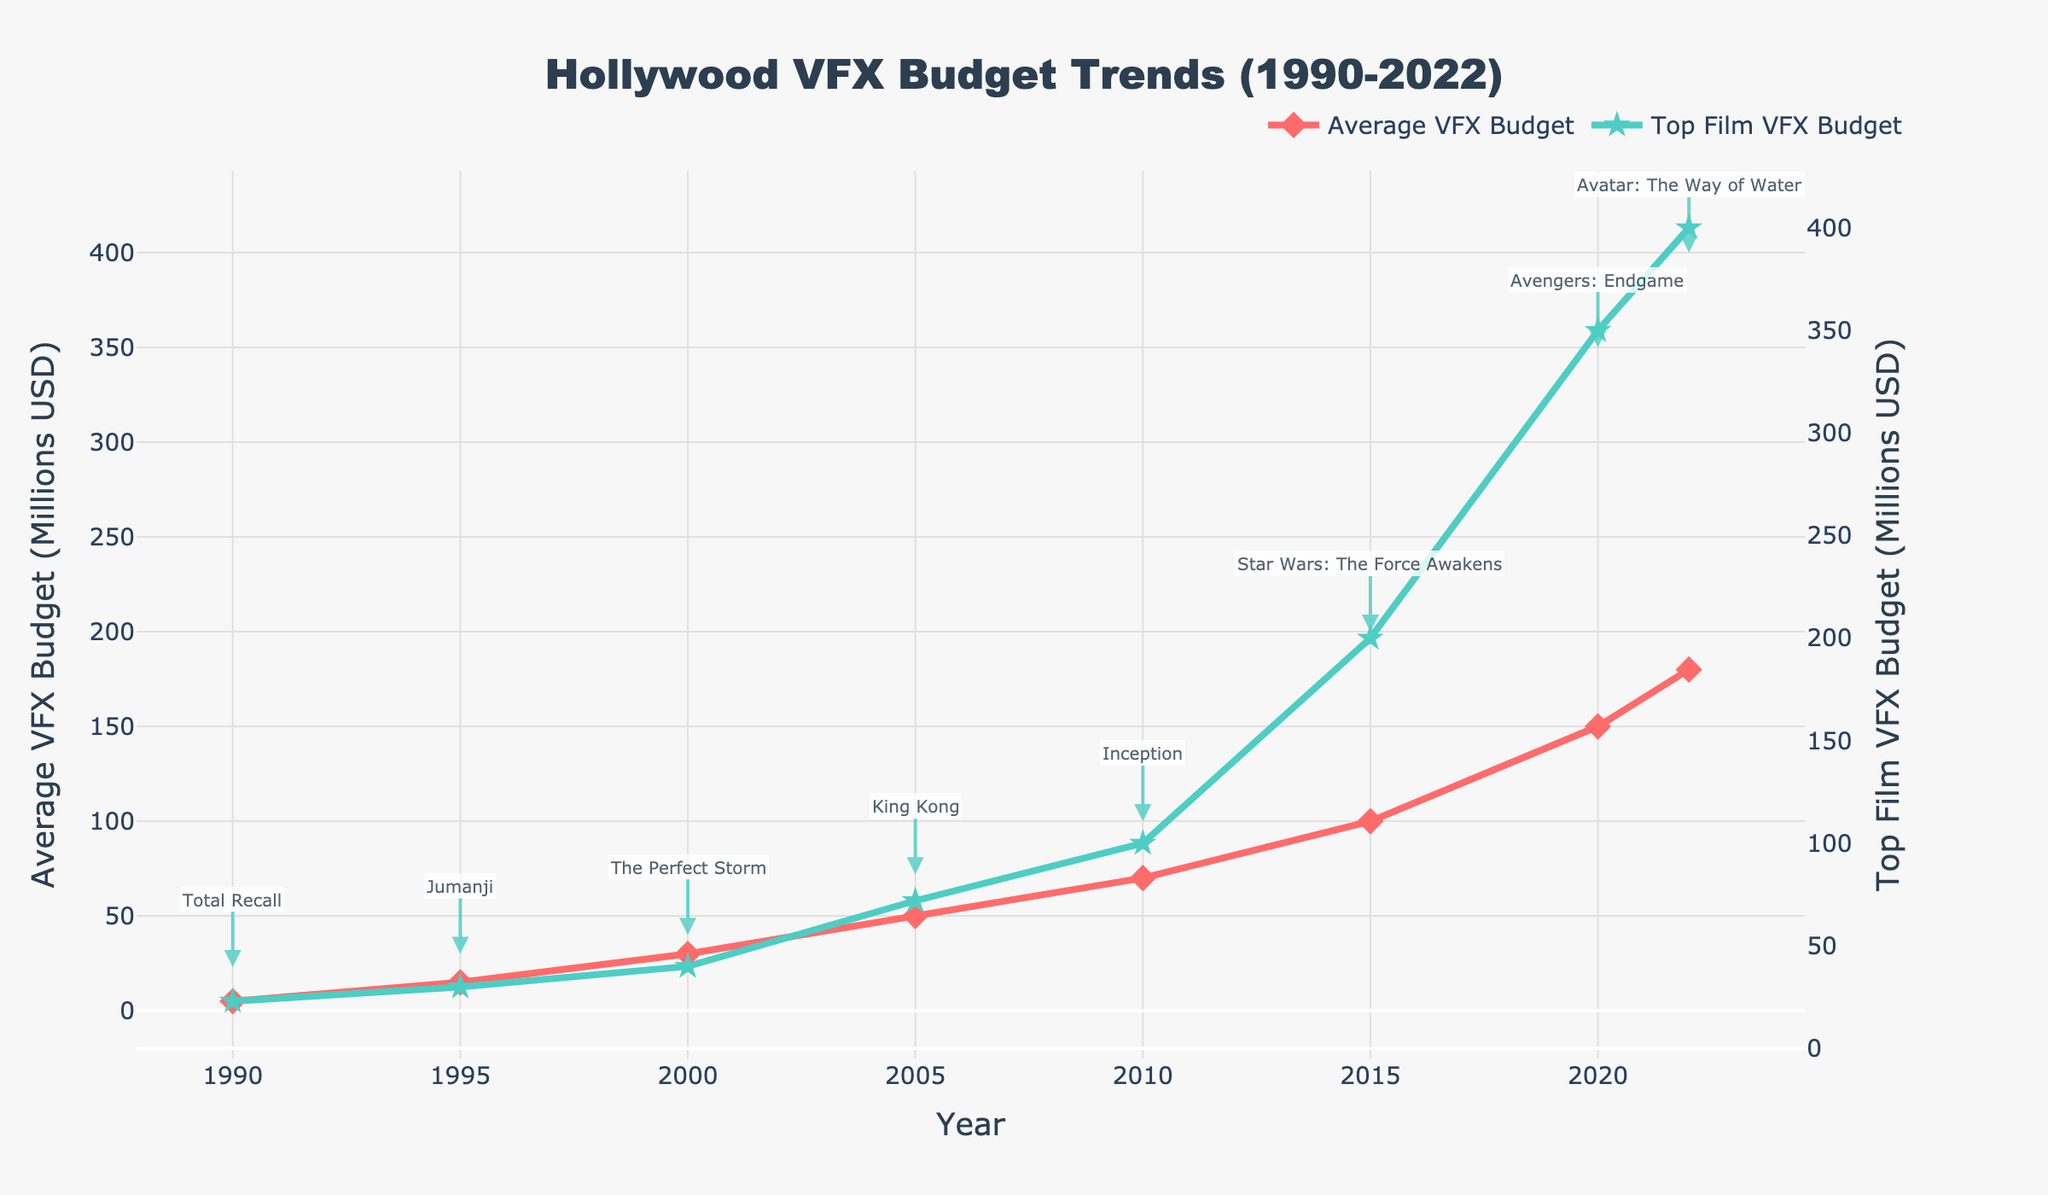What is the trend in the average VFX budget from 1990 to 2022? The chart shows an upward trend in the average VFX budget for Hollywood productions. Starting from 5 million USD in 1990, it increased to 180 million USD in 2022 with a few significant jumps, particularly around 1995, 2000, 2005, and 2010.
Answer: Upward trend How much did the VFX budget for the top film increase from 2000 to 2022? The VFX budget for the top film in 2000 was 40 million USD, and in 2022 it was 400 million USD. Subtract the 2000 budget from the 2022 budget: 400 - 40 = 360 million USD.
Answer: 360 million USD Which year had the largest gap between the average VFX budget and the top film VFX budget? The largest gap appears in 2022. The average VFX budget was 180 million USD and the top film VFX budget was 400 million USD. The difference is 400 - 180 = 220 million USD, which is visually the largest gap in the chart.
Answer: 2022 What is the film associated with the highest VFX budget in 2022? The chart annotates "Avatar: The Way of Water" as the film with the highest VFX budget in 2022.
Answer: Avatar: The Way of Water During which period did the average VFX budget see the most significant increase? The average VFX budget saw the most significant increase between 2010 and 2015, jumping from 70 million USD to 100 million USD, a difference of 30 million USD.
Answer: 2010-2015 How do the trends in the average and top film VFX budgets compare? Both the average and top film VFX budgets show an increasing trend, but the top film VFX budget increases at a faster rate, especially noticeable since 2010.
Answer: Both increase, but top film VFX budget increases faster What was the VFX budget for "Total Recall" in 1990? The chart annotates the VFX budget for "Total Recall" in 1990 at 23 million USD.
Answer: 23 million USD Was the VFX budget for "Inception" in 2010 higher or lower than the average VFX budget that year? The VFX budget for "Inception" in 2010 was 100 million USD, while the average VFX budget that year was 70 million USD. 100 million USD is higher than 70 million USD.
Answer: Higher 